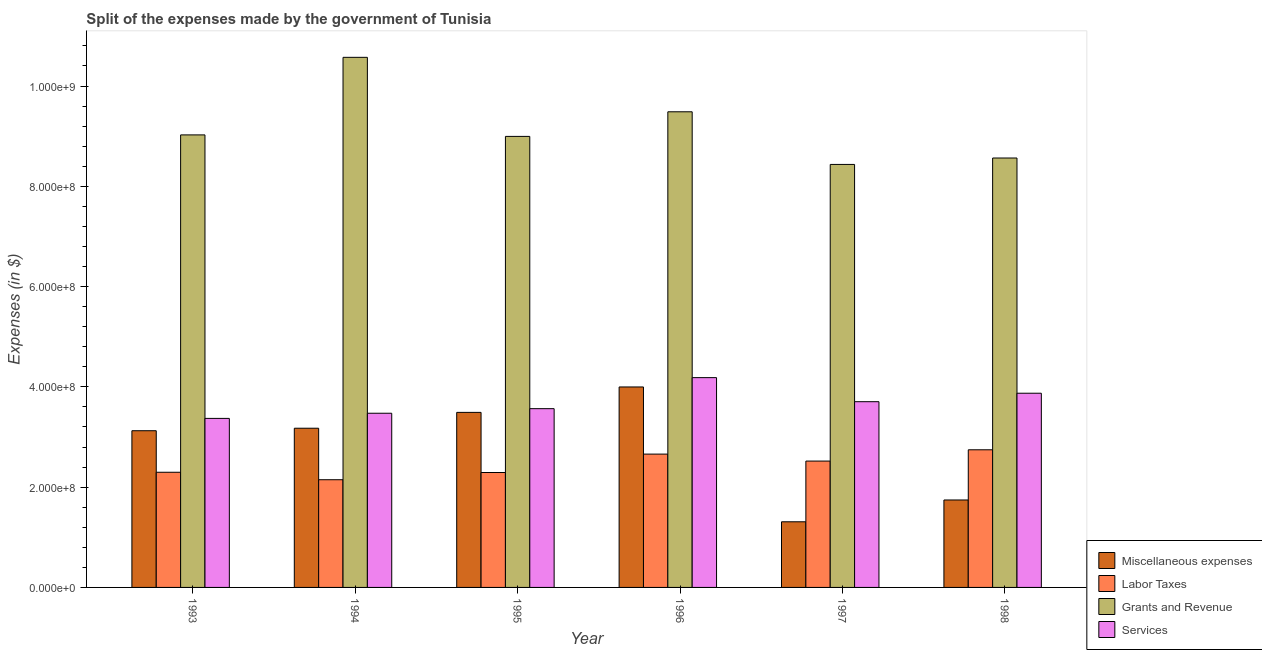How many different coloured bars are there?
Provide a short and direct response. 4. How many groups of bars are there?
Provide a short and direct response. 6. How many bars are there on the 6th tick from the left?
Ensure brevity in your answer.  4. How many bars are there on the 5th tick from the right?
Give a very brief answer. 4. What is the amount spent on miscellaneous expenses in 1997?
Offer a very short reply. 1.31e+08. Across all years, what is the maximum amount spent on miscellaneous expenses?
Ensure brevity in your answer.  4.00e+08. Across all years, what is the minimum amount spent on labor taxes?
Offer a very short reply. 2.15e+08. What is the total amount spent on labor taxes in the graph?
Provide a succinct answer. 1.47e+09. What is the difference between the amount spent on labor taxes in 1995 and that in 1997?
Make the answer very short. -2.28e+07. What is the difference between the amount spent on grants and revenue in 1995 and the amount spent on labor taxes in 1998?
Make the answer very short. 4.31e+07. What is the average amount spent on labor taxes per year?
Your answer should be compact. 2.44e+08. In how many years, is the amount spent on services greater than 160000000 $?
Make the answer very short. 6. What is the ratio of the amount spent on services in 1995 to that in 1997?
Give a very brief answer. 0.96. Is the amount spent on miscellaneous expenses in 1994 less than that in 1996?
Your response must be concise. Yes. What is the difference between the highest and the second highest amount spent on miscellaneous expenses?
Give a very brief answer. 5.07e+07. What is the difference between the highest and the lowest amount spent on services?
Your response must be concise. 8.13e+07. Is the sum of the amount spent on services in 1993 and 1998 greater than the maximum amount spent on grants and revenue across all years?
Offer a terse response. Yes. What does the 3rd bar from the left in 1996 represents?
Offer a very short reply. Grants and Revenue. What does the 1st bar from the right in 1995 represents?
Ensure brevity in your answer.  Services. Is it the case that in every year, the sum of the amount spent on miscellaneous expenses and amount spent on labor taxes is greater than the amount spent on grants and revenue?
Offer a terse response. No. How many bars are there?
Make the answer very short. 24. Are all the bars in the graph horizontal?
Offer a very short reply. No. How many years are there in the graph?
Provide a short and direct response. 6. Are the values on the major ticks of Y-axis written in scientific E-notation?
Offer a terse response. Yes. Does the graph contain any zero values?
Give a very brief answer. No. Where does the legend appear in the graph?
Ensure brevity in your answer.  Bottom right. How many legend labels are there?
Your answer should be very brief. 4. How are the legend labels stacked?
Your answer should be very brief. Vertical. What is the title of the graph?
Make the answer very short. Split of the expenses made by the government of Tunisia. Does "Natural Gas" appear as one of the legend labels in the graph?
Offer a very short reply. No. What is the label or title of the X-axis?
Provide a short and direct response. Year. What is the label or title of the Y-axis?
Keep it short and to the point. Expenses (in $). What is the Expenses (in $) in Miscellaneous expenses in 1993?
Provide a succinct answer. 3.12e+08. What is the Expenses (in $) in Labor Taxes in 1993?
Your answer should be compact. 2.30e+08. What is the Expenses (in $) of Grants and Revenue in 1993?
Give a very brief answer. 9.02e+08. What is the Expenses (in $) in Services in 1993?
Ensure brevity in your answer.  3.37e+08. What is the Expenses (in $) of Miscellaneous expenses in 1994?
Keep it short and to the point. 3.18e+08. What is the Expenses (in $) of Labor Taxes in 1994?
Ensure brevity in your answer.  2.15e+08. What is the Expenses (in $) of Grants and Revenue in 1994?
Offer a very short reply. 1.06e+09. What is the Expenses (in $) of Services in 1994?
Your answer should be very brief. 3.47e+08. What is the Expenses (in $) in Miscellaneous expenses in 1995?
Keep it short and to the point. 3.49e+08. What is the Expenses (in $) of Labor Taxes in 1995?
Provide a short and direct response. 2.29e+08. What is the Expenses (in $) of Grants and Revenue in 1995?
Your answer should be very brief. 9.00e+08. What is the Expenses (in $) of Services in 1995?
Keep it short and to the point. 3.56e+08. What is the Expenses (in $) of Miscellaneous expenses in 1996?
Give a very brief answer. 4.00e+08. What is the Expenses (in $) of Labor Taxes in 1996?
Provide a succinct answer. 2.66e+08. What is the Expenses (in $) of Grants and Revenue in 1996?
Keep it short and to the point. 9.49e+08. What is the Expenses (in $) in Services in 1996?
Provide a short and direct response. 4.18e+08. What is the Expenses (in $) of Miscellaneous expenses in 1997?
Your answer should be very brief. 1.31e+08. What is the Expenses (in $) in Labor Taxes in 1997?
Keep it short and to the point. 2.52e+08. What is the Expenses (in $) in Grants and Revenue in 1997?
Make the answer very short. 8.44e+08. What is the Expenses (in $) of Services in 1997?
Ensure brevity in your answer.  3.70e+08. What is the Expenses (in $) in Miscellaneous expenses in 1998?
Make the answer very short. 1.74e+08. What is the Expenses (in $) in Labor Taxes in 1998?
Keep it short and to the point. 2.74e+08. What is the Expenses (in $) of Grants and Revenue in 1998?
Offer a terse response. 8.56e+08. What is the Expenses (in $) of Services in 1998?
Your answer should be compact. 3.87e+08. Across all years, what is the maximum Expenses (in $) in Miscellaneous expenses?
Ensure brevity in your answer.  4.00e+08. Across all years, what is the maximum Expenses (in $) of Labor Taxes?
Make the answer very short. 2.74e+08. Across all years, what is the maximum Expenses (in $) of Grants and Revenue?
Keep it short and to the point. 1.06e+09. Across all years, what is the maximum Expenses (in $) in Services?
Offer a terse response. 4.18e+08. Across all years, what is the minimum Expenses (in $) in Miscellaneous expenses?
Offer a terse response. 1.31e+08. Across all years, what is the minimum Expenses (in $) of Labor Taxes?
Give a very brief answer. 2.15e+08. Across all years, what is the minimum Expenses (in $) of Grants and Revenue?
Ensure brevity in your answer.  8.44e+08. Across all years, what is the minimum Expenses (in $) of Services?
Give a very brief answer. 3.37e+08. What is the total Expenses (in $) in Miscellaneous expenses in the graph?
Ensure brevity in your answer.  1.68e+09. What is the total Expenses (in $) in Labor Taxes in the graph?
Offer a very short reply. 1.47e+09. What is the total Expenses (in $) in Grants and Revenue in the graph?
Ensure brevity in your answer.  5.51e+09. What is the total Expenses (in $) of Services in the graph?
Offer a terse response. 2.22e+09. What is the difference between the Expenses (in $) in Miscellaneous expenses in 1993 and that in 1994?
Provide a succinct answer. -5.00e+06. What is the difference between the Expenses (in $) of Labor Taxes in 1993 and that in 1994?
Offer a very short reply. 1.49e+07. What is the difference between the Expenses (in $) in Grants and Revenue in 1993 and that in 1994?
Make the answer very short. -1.55e+08. What is the difference between the Expenses (in $) of Services in 1993 and that in 1994?
Your answer should be very brief. -1.03e+07. What is the difference between the Expenses (in $) of Miscellaneous expenses in 1993 and that in 1995?
Offer a very short reply. -3.66e+07. What is the difference between the Expenses (in $) of Labor Taxes in 1993 and that in 1995?
Your answer should be very brief. 5.00e+05. What is the difference between the Expenses (in $) in Grants and Revenue in 1993 and that in 1995?
Give a very brief answer. 3.00e+06. What is the difference between the Expenses (in $) in Services in 1993 and that in 1995?
Your answer should be compact. -1.94e+07. What is the difference between the Expenses (in $) of Miscellaneous expenses in 1993 and that in 1996?
Make the answer very short. -8.73e+07. What is the difference between the Expenses (in $) in Labor Taxes in 1993 and that in 1996?
Give a very brief answer. -3.62e+07. What is the difference between the Expenses (in $) of Grants and Revenue in 1993 and that in 1996?
Your response must be concise. -4.61e+07. What is the difference between the Expenses (in $) of Services in 1993 and that in 1996?
Keep it short and to the point. -8.13e+07. What is the difference between the Expenses (in $) of Miscellaneous expenses in 1993 and that in 1997?
Your response must be concise. 1.82e+08. What is the difference between the Expenses (in $) of Labor Taxes in 1993 and that in 1997?
Provide a short and direct response. -2.23e+07. What is the difference between the Expenses (in $) of Grants and Revenue in 1993 and that in 1997?
Offer a very short reply. 5.89e+07. What is the difference between the Expenses (in $) in Services in 1993 and that in 1997?
Ensure brevity in your answer.  -3.33e+07. What is the difference between the Expenses (in $) of Miscellaneous expenses in 1993 and that in 1998?
Offer a terse response. 1.38e+08. What is the difference between the Expenses (in $) in Labor Taxes in 1993 and that in 1998?
Offer a very short reply. -4.48e+07. What is the difference between the Expenses (in $) in Grants and Revenue in 1993 and that in 1998?
Your answer should be very brief. 4.61e+07. What is the difference between the Expenses (in $) in Services in 1993 and that in 1998?
Provide a short and direct response. -5.02e+07. What is the difference between the Expenses (in $) of Miscellaneous expenses in 1994 and that in 1995?
Your answer should be very brief. -3.16e+07. What is the difference between the Expenses (in $) in Labor Taxes in 1994 and that in 1995?
Provide a succinct answer. -1.44e+07. What is the difference between the Expenses (in $) of Grants and Revenue in 1994 and that in 1995?
Your answer should be compact. 1.58e+08. What is the difference between the Expenses (in $) of Services in 1994 and that in 1995?
Provide a short and direct response. -9.10e+06. What is the difference between the Expenses (in $) of Miscellaneous expenses in 1994 and that in 1996?
Provide a short and direct response. -8.23e+07. What is the difference between the Expenses (in $) of Labor Taxes in 1994 and that in 1996?
Your answer should be compact. -5.11e+07. What is the difference between the Expenses (in $) in Grants and Revenue in 1994 and that in 1996?
Your answer should be compact. 1.09e+08. What is the difference between the Expenses (in $) of Services in 1994 and that in 1996?
Provide a short and direct response. -7.10e+07. What is the difference between the Expenses (in $) of Miscellaneous expenses in 1994 and that in 1997?
Your answer should be very brief. 1.87e+08. What is the difference between the Expenses (in $) in Labor Taxes in 1994 and that in 1997?
Offer a terse response. -3.72e+07. What is the difference between the Expenses (in $) of Grants and Revenue in 1994 and that in 1997?
Ensure brevity in your answer.  2.14e+08. What is the difference between the Expenses (in $) of Services in 1994 and that in 1997?
Your response must be concise. -2.30e+07. What is the difference between the Expenses (in $) in Miscellaneous expenses in 1994 and that in 1998?
Ensure brevity in your answer.  1.43e+08. What is the difference between the Expenses (in $) of Labor Taxes in 1994 and that in 1998?
Offer a terse response. -5.97e+07. What is the difference between the Expenses (in $) in Grants and Revenue in 1994 and that in 1998?
Offer a very short reply. 2.01e+08. What is the difference between the Expenses (in $) of Services in 1994 and that in 1998?
Give a very brief answer. -3.99e+07. What is the difference between the Expenses (in $) of Miscellaneous expenses in 1995 and that in 1996?
Ensure brevity in your answer.  -5.07e+07. What is the difference between the Expenses (in $) in Labor Taxes in 1995 and that in 1996?
Give a very brief answer. -3.67e+07. What is the difference between the Expenses (in $) in Grants and Revenue in 1995 and that in 1996?
Your answer should be very brief. -4.91e+07. What is the difference between the Expenses (in $) in Services in 1995 and that in 1996?
Offer a very short reply. -6.19e+07. What is the difference between the Expenses (in $) in Miscellaneous expenses in 1995 and that in 1997?
Make the answer very short. 2.18e+08. What is the difference between the Expenses (in $) of Labor Taxes in 1995 and that in 1997?
Offer a very short reply. -2.28e+07. What is the difference between the Expenses (in $) of Grants and Revenue in 1995 and that in 1997?
Provide a succinct answer. 5.59e+07. What is the difference between the Expenses (in $) in Services in 1995 and that in 1997?
Give a very brief answer. -1.39e+07. What is the difference between the Expenses (in $) of Miscellaneous expenses in 1995 and that in 1998?
Offer a terse response. 1.75e+08. What is the difference between the Expenses (in $) in Labor Taxes in 1995 and that in 1998?
Offer a terse response. -4.53e+07. What is the difference between the Expenses (in $) of Grants and Revenue in 1995 and that in 1998?
Give a very brief answer. 4.31e+07. What is the difference between the Expenses (in $) of Services in 1995 and that in 1998?
Offer a terse response. -3.08e+07. What is the difference between the Expenses (in $) of Miscellaneous expenses in 1996 and that in 1997?
Keep it short and to the point. 2.69e+08. What is the difference between the Expenses (in $) of Labor Taxes in 1996 and that in 1997?
Offer a terse response. 1.39e+07. What is the difference between the Expenses (in $) of Grants and Revenue in 1996 and that in 1997?
Make the answer very short. 1.05e+08. What is the difference between the Expenses (in $) of Services in 1996 and that in 1997?
Offer a terse response. 4.80e+07. What is the difference between the Expenses (in $) in Miscellaneous expenses in 1996 and that in 1998?
Ensure brevity in your answer.  2.25e+08. What is the difference between the Expenses (in $) of Labor Taxes in 1996 and that in 1998?
Provide a short and direct response. -8.60e+06. What is the difference between the Expenses (in $) in Grants and Revenue in 1996 and that in 1998?
Your response must be concise. 9.22e+07. What is the difference between the Expenses (in $) of Services in 1996 and that in 1998?
Keep it short and to the point. 3.11e+07. What is the difference between the Expenses (in $) of Miscellaneous expenses in 1997 and that in 1998?
Give a very brief answer. -4.35e+07. What is the difference between the Expenses (in $) in Labor Taxes in 1997 and that in 1998?
Your response must be concise. -2.25e+07. What is the difference between the Expenses (in $) of Grants and Revenue in 1997 and that in 1998?
Keep it short and to the point. -1.28e+07. What is the difference between the Expenses (in $) of Services in 1997 and that in 1998?
Provide a succinct answer. -1.69e+07. What is the difference between the Expenses (in $) in Miscellaneous expenses in 1993 and the Expenses (in $) in Labor Taxes in 1994?
Ensure brevity in your answer.  9.77e+07. What is the difference between the Expenses (in $) of Miscellaneous expenses in 1993 and the Expenses (in $) of Grants and Revenue in 1994?
Your answer should be very brief. -7.45e+08. What is the difference between the Expenses (in $) in Miscellaneous expenses in 1993 and the Expenses (in $) in Services in 1994?
Provide a succinct answer. -3.49e+07. What is the difference between the Expenses (in $) in Labor Taxes in 1993 and the Expenses (in $) in Grants and Revenue in 1994?
Offer a terse response. -8.28e+08. What is the difference between the Expenses (in $) in Labor Taxes in 1993 and the Expenses (in $) in Services in 1994?
Your response must be concise. -1.18e+08. What is the difference between the Expenses (in $) of Grants and Revenue in 1993 and the Expenses (in $) of Services in 1994?
Your answer should be very brief. 5.55e+08. What is the difference between the Expenses (in $) in Miscellaneous expenses in 1993 and the Expenses (in $) in Labor Taxes in 1995?
Your answer should be compact. 8.33e+07. What is the difference between the Expenses (in $) of Miscellaneous expenses in 1993 and the Expenses (in $) of Grants and Revenue in 1995?
Keep it short and to the point. -5.87e+08. What is the difference between the Expenses (in $) of Miscellaneous expenses in 1993 and the Expenses (in $) of Services in 1995?
Your answer should be very brief. -4.40e+07. What is the difference between the Expenses (in $) of Labor Taxes in 1993 and the Expenses (in $) of Grants and Revenue in 1995?
Your answer should be very brief. -6.70e+08. What is the difference between the Expenses (in $) of Labor Taxes in 1993 and the Expenses (in $) of Services in 1995?
Provide a succinct answer. -1.27e+08. What is the difference between the Expenses (in $) of Grants and Revenue in 1993 and the Expenses (in $) of Services in 1995?
Provide a succinct answer. 5.46e+08. What is the difference between the Expenses (in $) in Miscellaneous expenses in 1993 and the Expenses (in $) in Labor Taxes in 1996?
Give a very brief answer. 4.66e+07. What is the difference between the Expenses (in $) in Miscellaneous expenses in 1993 and the Expenses (in $) in Grants and Revenue in 1996?
Your answer should be very brief. -6.36e+08. What is the difference between the Expenses (in $) in Miscellaneous expenses in 1993 and the Expenses (in $) in Services in 1996?
Provide a short and direct response. -1.06e+08. What is the difference between the Expenses (in $) in Labor Taxes in 1993 and the Expenses (in $) in Grants and Revenue in 1996?
Ensure brevity in your answer.  -7.19e+08. What is the difference between the Expenses (in $) in Labor Taxes in 1993 and the Expenses (in $) in Services in 1996?
Give a very brief answer. -1.89e+08. What is the difference between the Expenses (in $) of Grants and Revenue in 1993 and the Expenses (in $) of Services in 1996?
Provide a short and direct response. 4.84e+08. What is the difference between the Expenses (in $) in Miscellaneous expenses in 1993 and the Expenses (in $) in Labor Taxes in 1997?
Offer a terse response. 6.05e+07. What is the difference between the Expenses (in $) of Miscellaneous expenses in 1993 and the Expenses (in $) of Grants and Revenue in 1997?
Provide a succinct answer. -5.31e+08. What is the difference between the Expenses (in $) in Miscellaneous expenses in 1993 and the Expenses (in $) in Services in 1997?
Your answer should be compact. -5.79e+07. What is the difference between the Expenses (in $) in Labor Taxes in 1993 and the Expenses (in $) in Grants and Revenue in 1997?
Ensure brevity in your answer.  -6.14e+08. What is the difference between the Expenses (in $) in Labor Taxes in 1993 and the Expenses (in $) in Services in 1997?
Provide a short and direct response. -1.41e+08. What is the difference between the Expenses (in $) of Grants and Revenue in 1993 and the Expenses (in $) of Services in 1997?
Give a very brief answer. 5.32e+08. What is the difference between the Expenses (in $) of Miscellaneous expenses in 1993 and the Expenses (in $) of Labor Taxes in 1998?
Provide a succinct answer. 3.80e+07. What is the difference between the Expenses (in $) of Miscellaneous expenses in 1993 and the Expenses (in $) of Grants and Revenue in 1998?
Your response must be concise. -5.44e+08. What is the difference between the Expenses (in $) of Miscellaneous expenses in 1993 and the Expenses (in $) of Services in 1998?
Ensure brevity in your answer.  -7.48e+07. What is the difference between the Expenses (in $) of Labor Taxes in 1993 and the Expenses (in $) of Grants and Revenue in 1998?
Your response must be concise. -6.27e+08. What is the difference between the Expenses (in $) of Labor Taxes in 1993 and the Expenses (in $) of Services in 1998?
Give a very brief answer. -1.58e+08. What is the difference between the Expenses (in $) in Grants and Revenue in 1993 and the Expenses (in $) in Services in 1998?
Provide a short and direct response. 5.15e+08. What is the difference between the Expenses (in $) in Miscellaneous expenses in 1994 and the Expenses (in $) in Labor Taxes in 1995?
Your answer should be very brief. 8.83e+07. What is the difference between the Expenses (in $) in Miscellaneous expenses in 1994 and the Expenses (in $) in Grants and Revenue in 1995?
Give a very brief answer. -5.82e+08. What is the difference between the Expenses (in $) in Miscellaneous expenses in 1994 and the Expenses (in $) in Services in 1995?
Provide a succinct answer. -3.90e+07. What is the difference between the Expenses (in $) in Labor Taxes in 1994 and the Expenses (in $) in Grants and Revenue in 1995?
Make the answer very short. -6.85e+08. What is the difference between the Expenses (in $) of Labor Taxes in 1994 and the Expenses (in $) of Services in 1995?
Provide a succinct answer. -1.42e+08. What is the difference between the Expenses (in $) of Grants and Revenue in 1994 and the Expenses (in $) of Services in 1995?
Your response must be concise. 7.01e+08. What is the difference between the Expenses (in $) in Miscellaneous expenses in 1994 and the Expenses (in $) in Labor Taxes in 1996?
Ensure brevity in your answer.  5.16e+07. What is the difference between the Expenses (in $) of Miscellaneous expenses in 1994 and the Expenses (in $) of Grants and Revenue in 1996?
Your response must be concise. -6.31e+08. What is the difference between the Expenses (in $) of Miscellaneous expenses in 1994 and the Expenses (in $) of Services in 1996?
Provide a short and direct response. -1.01e+08. What is the difference between the Expenses (in $) of Labor Taxes in 1994 and the Expenses (in $) of Grants and Revenue in 1996?
Give a very brief answer. -7.34e+08. What is the difference between the Expenses (in $) of Labor Taxes in 1994 and the Expenses (in $) of Services in 1996?
Make the answer very short. -2.04e+08. What is the difference between the Expenses (in $) of Grants and Revenue in 1994 and the Expenses (in $) of Services in 1996?
Your answer should be very brief. 6.39e+08. What is the difference between the Expenses (in $) in Miscellaneous expenses in 1994 and the Expenses (in $) in Labor Taxes in 1997?
Provide a short and direct response. 6.55e+07. What is the difference between the Expenses (in $) of Miscellaneous expenses in 1994 and the Expenses (in $) of Grants and Revenue in 1997?
Offer a very short reply. -5.26e+08. What is the difference between the Expenses (in $) of Miscellaneous expenses in 1994 and the Expenses (in $) of Services in 1997?
Offer a terse response. -5.29e+07. What is the difference between the Expenses (in $) in Labor Taxes in 1994 and the Expenses (in $) in Grants and Revenue in 1997?
Make the answer very short. -6.29e+08. What is the difference between the Expenses (in $) of Labor Taxes in 1994 and the Expenses (in $) of Services in 1997?
Your answer should be very brief. -1.56e+08. What is the difference between the Expenses (in $) in Grants and Revenue in 1994 and the Expenses (in $) in Services in 1997?
Provide a short and direct response. 6.87e+08. What is the difference between the Expenses (in $) in Miscellaneous expenses in 1994 and the Expenses (in $) in Labor Taxes in 1998?
Provide a succinct answer. 4.30e+07. What is the difference between the Expenses (in $) in Miscellaneous expenses in 1994 and the Expenses (in $) in Grants and Revenue in 1998?
Your response must be concise. -5.39e+08. What is the difference between the Expenses (in $) of Miscellaneous expenses in 1994 and the Expenses (in $) of Services in 1998?
Make the answer very short. -6.98e+07. What is the difference between the Expenses (in $) in Labor Taxes in 1994 and the Expenses (in $) in Grants and Revenue in 1998?
Your answer should be compact. -6.42e+08. What is the difference between the Expenses (in $) in Labor Taxes in 1994 and the Expenses (in $) in Services in 1998?
Provide a succinct answer. -1.72e+08. What is the difference between the Expenses (in $) of Grants and Revenue in 1994 and the Expenses (in $) of Services in 1998?
Your response must be concise. 6.70e+08. What is the difference between the Expenses (in $) in Miscellaneous expenses in 1995 and the Expenses (in $) in Labor Taxes in 1996?
Offer a terse response. 8.32e+07. What is the difference between the Expenses (in $) of Miscellaneous expenses in 1995 and the Expenses (in $) of Grants and Revenue in 1996?
Give a very brief answer. -6.00e+08. What is the difference between the Expenses (in $) in Miscellaneous expenses in 1995 and the Expenses (in $) in Services in 1996?
Provide a short and direct response. -6.93e+07. What is the difference between the Expenses (in $) in Labor Taxes in 1995 and the Expenses (in $) in Grants and Revenue in 1996?
Give a very brief answer. -7.19e+08. What is the difference between the Expenses (in $) of Labor Taxes in 1995 and the Expenses (in $) of Services in 1996?
Provide a succinct answer. -1.89e+08. What is the difference between the Expenses (in $) in Grants and Revenue in 1995 and the Expenses (in $) in Services in 1996?
Keep it short and to the point. 4.81e+08. What is the difference between the Expenses (in $) of Miscellaneous expenses in 1995 and the Expenses (in $) of Labor Taxes in 1997?
Ensure brevity in your answer.  9.71e+07. What is the difference between the Expenses (in $) of Miscellaneous expenses in 1995 and the Expenses (in $) of Grants and Revenue in 1997?
Give a very brief answer. -4.94e+08. What is the difference between the Expenses (in $) in Miscellaneous expenses in 1995 and the Expenses (in $) in Services in 1997?
Provide a succinct answer. -2.13e+07. What is the difference between the Expenses (in $) in Labor Taxes in 1995 and the Expenses (in $) in Grants and Revenue in 1997?
Your response must be concise. -6.14e+08. What is the difference between the Expenses (in $) in Labor Taxes in 1995 and the Expenses (in $) in Services in 1997?
Provide a succinct answer. -1.41e+08. What is the difference between the Expenses (in $) in Grants and Revenue in 1995 and the Expenses (in $) in Services in 1997?
Your answer should be very brief. 5.29e+08. What is the difference between the Expenses (in $) in Miscellaneous expenses in 1995 and the Expenses (in $) in Labor Taxes in 1998?
Provide a short and direct response. 7.46e+07. What is the difference between the Expenses (in $) of Miscellaneous expenses in 1995 and the Expenses (in $) of Grants and Revenue in 1998?
Provide a short and direct response. -5.07e+08. What is the difference between the Expenses (in $) in Miscellaneous expenses in 1995 and the Expenses (in $) in Services in 1998?
Provide a succinct answer. -3.82e+07. What is the difference between the Expenses (in $) in Labor Taxes in 1995 and the Expenses (in $) in Grants and Revenue in 1998?
Make the answer very short. -6.27e+08. What is the difference between the Expenses (in $) of Labor Taxes in 1995 and the Expenses (in $) of Services in 1998?
Provide a short and direct response. -1.58e+08. What is the difference between the Expenses (in $) of Grants and Revenue in 1995 and the Expenses (in $) of Services in 1998?
Offer a terse response. 5.12e+08. What is the difference between the Expenses (in $) of Miscellaneous expenses in 1996 and the Expenses (in $) of Labor Taxes in 1997?
Your response must be concise. 1.48e+08. What is the difference between the Expenses (in $) of Miscellaneous expenses in 1996 and the Expenses (in $) of Grants and Revenue in 1997?
Keep it short and to the point. -4.44e+08. What is the difference between the Expenses (in $) of Miscellaneous expenses in 1996 and the Expenses (in $) of Services in 1997?
Your answer should be compact. 2.94e+07. What is the difference between the Expenses (in $) of Labor Taxes in 1996 and the Expenses (in $) of Grants and Revenue in 1997?
Offer a very short reply. -5.78e+08. What is the difference between the Expenses (in $) in Labor Taxes in 1996 and the Expenses (in $) in Services in 1997?
Ensure brevity in your answer.  -1.04e+08. What is the difference between the Expenses (in $) of Grants and Revenue in 1996 and the Expenses (in $) of Services in 1997?
Ensure brevity in your answer.  5.78e+08. What is the difference between the Expenses (in $) of Miscellaneous expenses in 1996 and the Expenses (in $) of Labor Taxes in 1998?
Offer a terse response. 1.25e+08. What is the difference between the Expenses (in $) of Miscellaneous expenses in 1996 and the Expenses (in $) of Grants and Revenue in 1998?
Your answer should be compact. -4.57e+08. What is the difference between the Expenses (in $) of Miscellaneous expenses in 1996 and the Expenses (in $) of Services in 1998?
Your response must be concise. 1.25e+07. What is the difference between the Expenses (in $) of Labor Taxes in 1996 and the Expenses (in $) of Grants and Revenue in 1998?
Keep it short and to the point. -5.90e+08. What is the difference between the Expenses (in $) in Labor Taxes in 1996 and the Expenses (in $) in Services in 1998?
Provide a succinct answer. -1.21e+08. What is the difference between the Expenses (in $) in Grants and Revenue in 1996 and the Expenses (in $) in Services in 1998?
Your answer should be compact. 5.61e+08. What is the difference between the Expenses (in $) of Miscellaneous expenses in 1997 and the Expenses (in $) of Labor Taxes in 1998?
Make the answer very short. -1.44e+08. What is the difference between the Expenses (in $) of Miscellaneous expenses in 1997 and the Expenses (in $) of Grants and Revenue in 1998?
Your response must be concise. -7.26e+08. What is the difference between the Expenses (in $) of Miscellaneous expenses in 1997 and the Expenses (in $) of Services in 1998?
Offer a very short reply. -2.56e+08. What is the difference between the Expenses (in $) of Labor Taxes in 1997 and the Expenses (in $) of Grants and Revenue in 1998?
Make the answer very short. -6.04e+08. What is the difference between the Expenses (in $) of Labor Taxes in 1997 and the Expenses (in $) of Services in 1998?
Your answer should be very brief. -1.35e+08. What is the difference between the Expenses (in $) in Grants and Revenue in 1997 and the Expenses (in $) in Services in 1998?
Your answer should be very brief. 4.56e+08. What is the average Expenses (in $) of Miscellaneous expenses per year?
Make the answer very short. 2.81e+08. What is the average Expenses (in $) in Labor Taxes per year?
Keep it short and to the point. 2.44e+08. What is the average Expenses (in $) in Grants and Revenue per year?
Give a very brief answer. 9.18e+08. What is the average Expenses (in $) in Services per year?
Your response must be concise. 3.70e+08. In the year 1993, what is the difference between the Expenses (in $) in Miscellaneous expenses and Expenses (in $) in Labor Taxes?
Give a very brief answer. 8.28e+07. In the year 1993, what is the difference between the Expenses (in $) in Miscellaneous expenses and Expenses (in $) in Grants and Revenue?
Offer a very short reply. -5.90e+08. In the year 1993, what is the difference between the Expenses (in $) of Miscellaneous expenses and Expenses (in $) of Services?
Offer a very short reply. -2.46e+07. In the year 1993, what is the difference between the Expenses (in $) of Labor Taxes and Expenses (in $) of Grants and Revenue?
Provide a short and direct response. -6.73e+08. In the year 1993, what is the difference between the Expenses (in $) of Labor Taxes and Expenses (in $) of Services?
Provide a succinct answer. -1.07e+08. In the year 1993, what is the difference between the Expenses (in $) in Grants and Revenue and Expenses (in $) in Services?
Your answer should be very brief. 5.65e+08. In the year 1994, what is the difference between the Expenses (in $) of Miscellaneous expenses and Expenses (in $) of Labor Taxes?
Keep it short and to the point. 1.03e+08. In the year 1994, what is the difference between the Expenses (in $) of Miscellaneous expenses and Expenses (in $) of Grants and Revenue?
Your response must be concise. -7.40e+08. In the year 1994, what is the difference between the Expenses (in $) of Miscellaneous expenses and Expenses (in $) of Services?
Give a very brief answer. -2.99e+07. In the year 1994, what is the difference between the Expenses (in $) in Labor Taxes and Expenses (in $) in Grants and Revenue?
Keep it short and to the point. -8.42e+08. In the year 1994, what is the difference between the Expenses (in $) in Labor Taxes and Expenses (in $) in Services?
Offer a very short reply. -1.33e+08. In the year 1994, what is the difference between the Expenses (in $) in Grants and Revenue and Expenses (in $) in Services?
Keep it short and to the point. 7.10e+08. In the year 1995, what is the difference between the Expenses (in $) in Miscellaneous expenses and Expenses (in $) in Labor Taxes?
Your answer should be very brief. 1.20e+08. In the year 1995, what is the difference between the Expenses (in $) in Miscellaneous expenses and Expenses (in $) in Grants and Revenue?
Provide a short and direct response. -5.50e+08. In the year 1995, what is the difference between the Expenses (in $) of Miscellaneous expenses and Expenses (in $) of Services?
Provide a short and direct response. -7.40e+06. In the year 1995, what is the difference between the Expenses (in $) of Labor Taxes and Expenses (in $) of Grants and Revenue?
Provide a short and direct response. -6.70e+08. In the year 1995, what is the difference between the Expenses (in $) of Labor Taxes and Expenses (in $) of Services?
Your answer should be very brief. -1.27e+08. In the year 1995, what is the difference between the Expenses (in $) in Grants and Revenue and Expenses (in $) in Services?
Give a very brief answer. 5.43e+08. In the year 1996, what is the difference between the Expenses (in $) in Miscellaneous expenses and Expenses (in $) in Labor Taxes?
Keep it short and to the point. 1.34e+08. In the year 1996, what is the difference between the Expenses (in $) of Miscellaneous expenses and Expenses (in $) of Grants and Revenue?
Offer a terse response. -5.49e+08. In the year 1996, what is the difference between the Expenses (in $) in Miscellaneous expenses and Expenses (in $) in Services?
Provide a short and direct response. -1.86e+07. In the year 1996, what is the difference between the Expenses (in $) of Labor Taxes and Expenses (in $) of Grants and Revenue?
Your answer should be very brief. -6.83e+08. In the year 1996, what is the difference between the Expenses (in $) of Labor Taxes and Expenses (in $) of Services?
Keep it short and to the point. -1.52e+08. In the year 1996, what is the difference between the Expenses (in $) of Grants and Revenue and Expenses (in $) of Services?
Provide a succinct answer. 5.30e+08. In the year 1997, what is the difference between the Expenses (in $) of Miscellaneous expenses and Expenses (in $) of Labor Taxes?
Provide a succinct answer. -1.21e+08. In the year 1997, what is the difference between the Expenses (in $) of Miscellaneous expenses and Expenses (in $) of Grants and Revenue?
Your response must be concise. -7.13e+08. In the year 1997, what is the difference between the Expenses (in $) in Miscellaneous expenses and Expenses (in $) in Services?
Keep it short and to the point. -2.40e+08. In the year 1997, what is the difference between the Expenses (in $) in Labor Taxes and Expenses (in $) in Grants and Revenue?
Ensure brevity in your answer.  -5.92e+08. In the year 1997, what is the difference between the Expenses (in $) of Labor Taxes and Expenses (in $) of Services?
Offer a very short reply. -1.18e+08. In the year 1997, what is the difference between the Expenses (in $) in Grants and Revenue and Expenses (in $) in Services?
Offer a terse response. 4.73e+08. In the year 1998, what is the difference between the Expenses (in $) in Miscellaneous expenses and Expenses (in $) in Labor Taxes?
Your response must be concise. -1.00e+08. In the year 1998, what is the difference between the Expenses (in $) of Miscellaneous expenses and Expenses (in $) of Grants and Revenue?
Keep it short and to the point. -6.82e+08. In the year 1998, what is the difference between the Expenses (in $) of Miscellaneous expenses and Expenses (in $) of Services?
Offer a very short reply. -2.13e+08. In the year 1998, what is the difference between the Expenses (in $) in Labor Taxes and Expenses (in $) in Grants and Revenue?
Provide a short and direct response. -5.82e+08. In the year 1998, what is the difference between the Expenses (in $) of Labor Taxes and Expenses (in $) of Services?
Provide a succinct answer. -1.13e+08. In the year 1998, what is the difference between the Expenses (in $) in Grants and Revenue and Expenses (in $) in Services?
Your answer should be compact. 4.69e+08. What is the ratio of the Expenses (in $) of Miscellaneous expenses in 1993 to that in 1994?
Your answer should be very brief. 0.98. What is the ratio of the Expenses (in $) in Labor Taxes in 1993 to that in 1994?
Your answer should be compact. 1.07. What is the ratio of the Expenses (in $) in Grants and Revenue in 1993 to that in 1994?
Offer a very short reply. 0.85. What is the ratio of the Expenses (in $) in Services in 1993 to that in 1994?
Make the answer very short. 0.97. What is the ratio of the Expenses (in $) of Miscellaneous expenses in 1993 to that in 1995?
Provide a short and direct response. 0.9. What is the ratio of the Expenses (in $) in Services in 1993 to that in 1995?
Make the answer very short. 0.95. What is the ratio of the Expenses (in $) in Miscellaneous expenses in 1993 to that in 1996?
Offer a very short reply. 0.78. What is the ratio of the Expenses (in $) in Labor Taxes in 1993 to that in 1996?
Your answer should be very brief. 0.86. What is the ratio of the Expenses (in $) of Grants and Revenue in 1993 to that in 1996?
Provide a short and direct response. 0.95. What is the ratio of the Expenses (in $) of Services in 1993 to that in 1996?
Your answer should be compact. 0.81. What is the ratio of the Expenses (in $) of Miscellaneous expenses in 1993 to that in 1997?
Give a very brief answer. 2.39. What is the ratio of the Expenses (in $) in Labor Taxes in 1993 to that in 1997?
Make the answer very short. 0.91. What is the ratio of the Expenses (in $) of Grants and Revenue in 1993 to that in 1997?
Offer a very short reply. 1.07. What is the ratio of the Expenses (in $) of Services in 1993 to that in 1997?
Give a very brief answer. 0.91. What is the ratio of the Expenses (in $) of Miscellaneous expenses in 1993 to that in 1998?
Your response must be concise. 1.79. What is the ratio of the Expenses (in $) of Labor Taxes in 1993 to that in 1998?
Make the answer very short. 0.84. What is the ratio of the Expenses (in $) of Grants and Revenue in 1993 to that in 1998?
Your answer should be compact. 1.05. What is the ratio of the Expenses (in $) of Services in 1993 to that in 1998?
Provide a succinct answer. 0.87. What is the ratio of the Expenses (in $) of Miscellaneous expenses in 1994 to that in 1995?
Offer a very short reply. 0.91. What is the ratio of the Expenses (in $) of Labor Taxes in 1994 to that in 1995?
Your answer should be very brief. 0.94. What is the ratio of the Expenses (in $) in Grants and Revenue in 1994 to that in 1995?
Your answer should be compact. 1.18. What is the ratio of the Expenses (in $) of Services in 1994 to that in 1995?
Keep it short and to the point. 0.97. What is the ratio of the Expenses (in $) in Miscellaneous expenses in 1994 to that in 1996?
Offer a very short reply. 0.79. What is the ratio of the Expenses (in $) of Labor Taxes in 1994 to that in 1996?
Provide a succinct answer. 0.81. What is the ratio of the Expenses (in $) in Grants and Revenue in 1994 to that in 1996?
Give a very brief answer. 1.11. What is the ratio of the Expenses (in $) in Services in 1994 to that in 1996?
Offer a very short reply. 0.83. What is the ratio of the Expenses (in $) of Miscellaneous expenses in 1994 to that in 1997?
Your response must be concise. 2.43. What is the ratio of the Expenses (in $) in Labor Taxes in 1994 to that in 1997?
Provide a succinct answer. 0.85. What is the ratio of the Expenses (in $) of Grants and Revenue in 1994 to that in 1997?
Your answer should be very brief. 1.25. What is the ratio of the Expenses (in $) of Services in 1994 to that in 1997?
Your answer should be very brief. 0.94. What is the ratio of the Expenses (in $) of Miscellaneous expenses in 1994 to that in 1998?
Provide a short and direct response. 1.82. What is the ratio of the Expenses (in $) of Labor Taxes in 1994 to that in 1998?
Offer a very short reply. 0.78. What is the ratio of the Expenses (in $) in Grants and Revenue in 1994 to that in 1998?
Make the answer very short. 1.23. What is the ratio of the Expenses (in $) of Services in 1994 to that in 1998?
Your answer should be compact. 0.9. What is the ratio of the Expenses (in $) of Miscellaneous expenses in 1995 to that in 1996?
Your answer should be very brief. 0.87. What is the ratio of the Expenses (in $) in Labor Taxes in 1995 to that in 1996?
Provide a short and direct response. 0.86. What is the ratio of the Expenses (in $) in Grants and Revenue in 1995 to that in 1996?
Offer a very short reply. 0.95. What is the ratio of the Expenses (in $) of Services in 1995 to that in 1996?
Offer a terse response. 0.85. What is the ratio of the Expenses (in $) in Miscellaneous expenses in 1995 to that in 1997?
Your response must be concise. 2.67. What is the ratio of the Expenses (in $) in Labor Taxes in 1995 to that in 1997?
Your answer should be very brief. 0.91. What is the ratio of the Expenses (in $) in Grants and Revenue in 1995 to that in 1997?
Your response must be concise. 1.07. What is the ratio of the Expenses (in $) in Services in 1995 to that in 1997?
Your response must be concise. 0.96. What is the ratio of the Expenses (in $) in Miscellaneous expenses in 1995 to that in 1998?
Make the answer very short. 2. What is the ratio of the Expenses (in $) in Labor Taxes in 1995 to that in 1998?
Ensure brevity in your answer.  0.83. What is the ratio of the Expenses (in $) in Grants and Revenue in 1995 to that in 1998?
Ensure brevity in your answer.  1.05. What is the ratio of the Expenses (in $) of Services in 1995 to that in 1998?
Provide a short and direct response. 0.92. What is the ratio of the Expenses (in $) of Miscellaneous expenses in 1996 to that in 1997?
Your answer should be very brief. 3.05. What is the ratio of the Expenses (in $) in Labor Taxes in 1996 to that in 1997?
Offer a very short reply. 1.06. What is the ratio of the Expenses (in $) of Grants and Revenue in 1996 to that in 1997?
Offer a very short reply. 1.12. What is the ratio of the Expenses (in $) of Services in 1996 to that in 1997?
Your answer should be compact. 1.13. What is the ratio of the Expenses (in $) of Miscellaneous expenses in 1996 to that in 1998?
Your response must be concise. 2.29. What is the ratio of the Expenses (in $) in Labor Taxes in 1996 to that in 1998?
Ensure brevity in your answer.  0.97. What is the ratio of the Expenses (in $) of Grants and Revenue in 1996 to that in 1998?
Your answer should be compact. 1.11. What is the ratio of the Expenses (in $) of Services in 1996 to that in 1998?
Give a very brief answer. 1.08. What is the ratio of the Expenses (in $) in Miscellaneous expenses in 1997 to that in 1998?
Provide a succinct answer. 0.75. What is the ratio of the Expenses (in $) of Labor Taxes in 1997 to that in 1998?
Keep it short and to the point. 0.92. What is the ratio of the Expenses (in $) in Grants and Revenue in 1997 to that in 1998?
Your response must be concise. 0.99. What is the ratio of the Expenses (in $) in Services in 1997 to that in 1998?
Offer a terse response. 0.96. What is the difference between the highest and the second highest Expenses (in $) of Miscellaneous expenses?
Offer a terse response. 5.07e+07. What is the difference between the highest and the second highest Expenses (in $) in Labor Taxes?
Keep it short and to the point. 8.60e+06. What is the difference between the highest and the second highest Expenses (in $) in Grants and Revenue?
Your answer should be very brief. 1.09e+08. What is the difference between the highest and the second highest Expenses (in $) of Services?
Your answer should be compact. 3.11e+07. What is the difference between the highest and the lowest Expenses (in $) of Miscellaneous expenses?
Give a very brief answer. 2.69e+08. What is the difference between the highest and the lowest Expenses (in $) of Labor Taxes?
Keep it short and to the point. 5.97e+07. What is the difference between the highest and the lowest Expenses (in $) of Grants and Revenue?
Keep it short and to the point. 2.14e+08. What is the difference between the highest and the lowest Expenses (in $) in Services?
Give a very brief answer. 8.13e+07. 